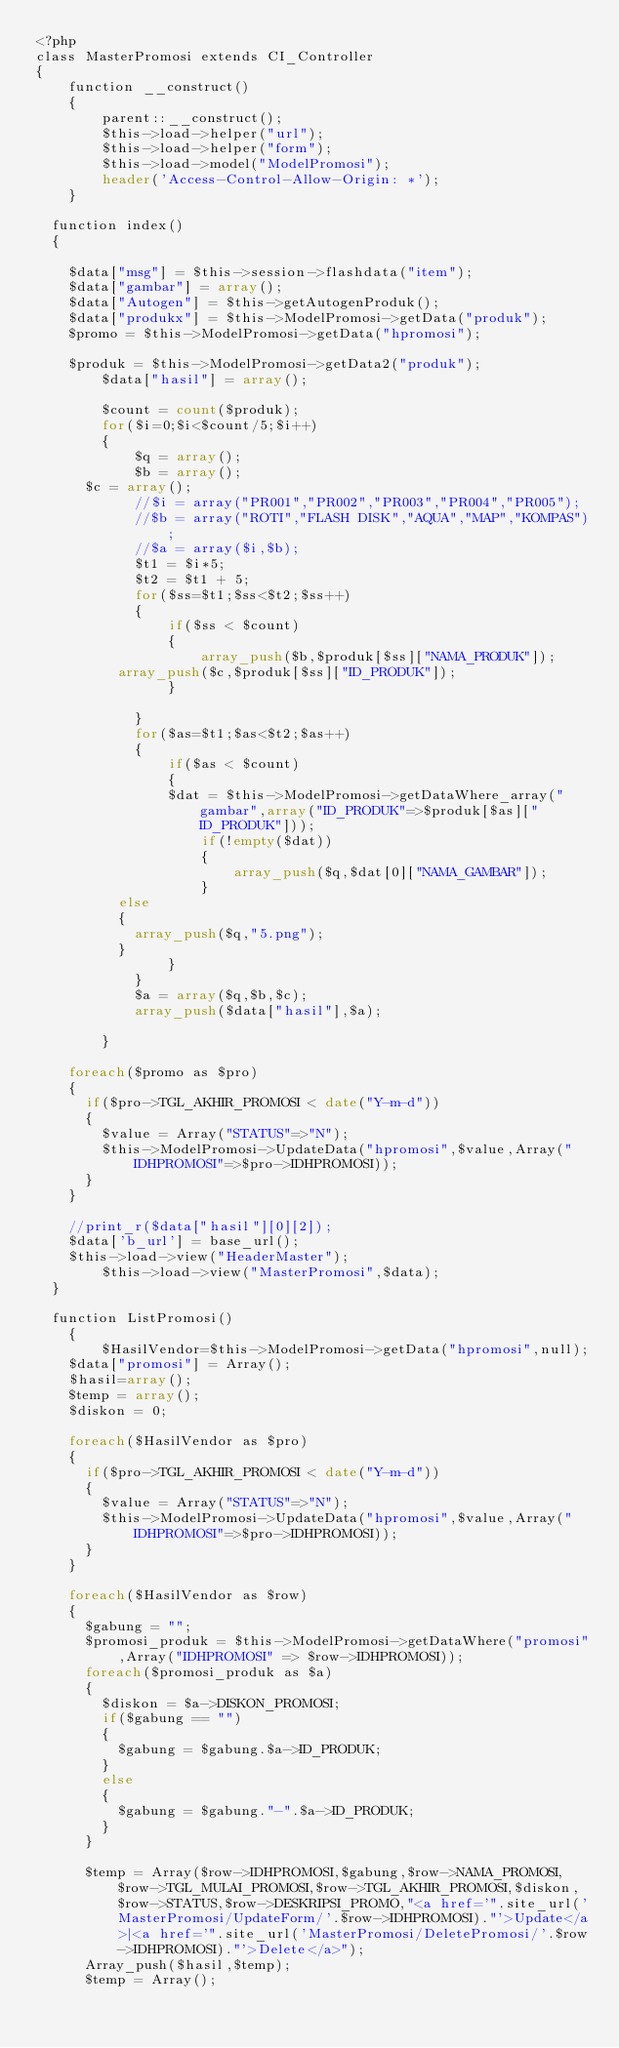<code> <loc_0><loc_0><loc_500><loc_500><_PHP_><?php
class MasterPromosi extends CI_Controller
{
    function __construct()
    {
        parent::__construct();
        $this->load->helper("url");
        $this->load->helper("form");
        $this->load->model("ModelPromosi");
        header('Access-Control-Allow-Origin: *');
    }

	function index()
	{
		
		$data["msg"] = $this->session->flashdata("item");
		$data["gambar"] = array();
		$data["Autogen"] = $this->getAutogenProduk(); 
		$data["produkx"] = $this->ModelPromosi->getData("produk");
		$promo = $this->ModelPromosi->getData("hpromosi");
		
		$produk = $this->ModelPromosi->getData2("produk");
        $data["hasil"] = array();
        
        $count = count($produk);
        for($i=0;$i<$count/5;$i++)
        {
            $q = array();
            $b = array();
			$c = array();
            //$i = array("PR001","PR002","PR003","PR004","PR005");
            //$b = array("ROTI","FLASH DISK","AQUA","MAP","KOMPAS");
            //$a = array($i,$b);
            $t1 = $i*5;
            $t2 = $t1 + 5;
            for($ss=$t1;$ss<$t2;$ss++)
            { 
                if($ss < $count)
                {
                    array_push($b,$produk[$ss]["NAMA_PRODUK"]);
					array_push($c,$produk[$ss]["ID_PRODUK"]);
                }
               
            }
            for($as=$t1;$as<$t2;$as++)
            {
                if($as < $count)
                {
                $dat = $this->ModelPromosi->getDataWhere_array("gambar",array("ID_PRODUK"=>$produk[$as]["ID_PRODUK"]));    
                    if(!empty($dat))
                    {
                        array_push($q,$dat[0]["NAMA_GAMBAR"]);
                    }
					else
					{
						array_push($q,"5.png");
					}
                }
            }
            $a = array($q,$b,$c);
            array_push($data["hasil"],$a);
			
        }
		
		foreach($promo as $pro)
		{
			if($pro->TGL_AKHIR_PROMOSI < date("Y-m-d"))
			{
				$value = Array("STATUS"=>"N");
				$this->ModelPromosi->UpdateData("hpromosi",$value,Array("IDHPROMOSI"=>$pro->IDHPROMOSI));
			}
		}
		
		//print_r($data["hasil"][0][2]);
		$data['b_url'] = base_url();
		$this->load->view("HeaderMaster");
        $this->load->view("MasterPromosi",$data);
	}
	
	function ListPromosi()
    {
        $HasilVendor=$this->ModelPromosi->getData("hpromosi",null);
		$data["promosi"] = Array();
		$hasil=array();
		$temp = array();
		$diskon = 0;
			
		foreach($HasilVendor as $pro)
		{
			if($pro->TGL_AKHIR_PROMOSI < date("Y-m-d"))
			{
				$value = Array("STATUS"=>"N");
				$this->ModelPromosi->UpdateData("hpromosi",$value,Array("IDHPROMOSI"=>$pro->IDHPROMOSI));
			}
		}	
			
		foreach($HasilVendor as $row)
		{
			$gabung = "";
			$promosi_produk = $this->ModelPromosi->getDataWhere("promosi",Array("IDHPROMOSI" => $row->IDHPROMOSI));
			foreach($promosi_produk as $a)
			{
				$diskon = $a->DISKON_PROMOSI;
				if($gabung == "")
				{
					$gabung = $gabung.$a->ID_PRODUK;
				}
				else
				{
					$gabung = $gabung."-".$a->ID_PRODUK;
				}
			}
			
			$temp = Array($row->IDHPROMOSI,$gabung,$row->NAMA_PROMOSI,$row->TGL_MULAI_PROMOSI,$row->TGL_AKHIR_PROMOSI,$diskon,$row->STATUS,$row->DESKRIPSI_PROMO,"<a href='".site_url('MasterPromosi/UpdateForm/'.$row->IDHPROMOSI)."'>Update</a>|<a href='".site_url('MasterPromosi/DeletePromosi/'.$row->IDHPROMOSI)."'>Delete</a>");
			Array_push($hasil,$temp);
			$temp = Array();</code> 